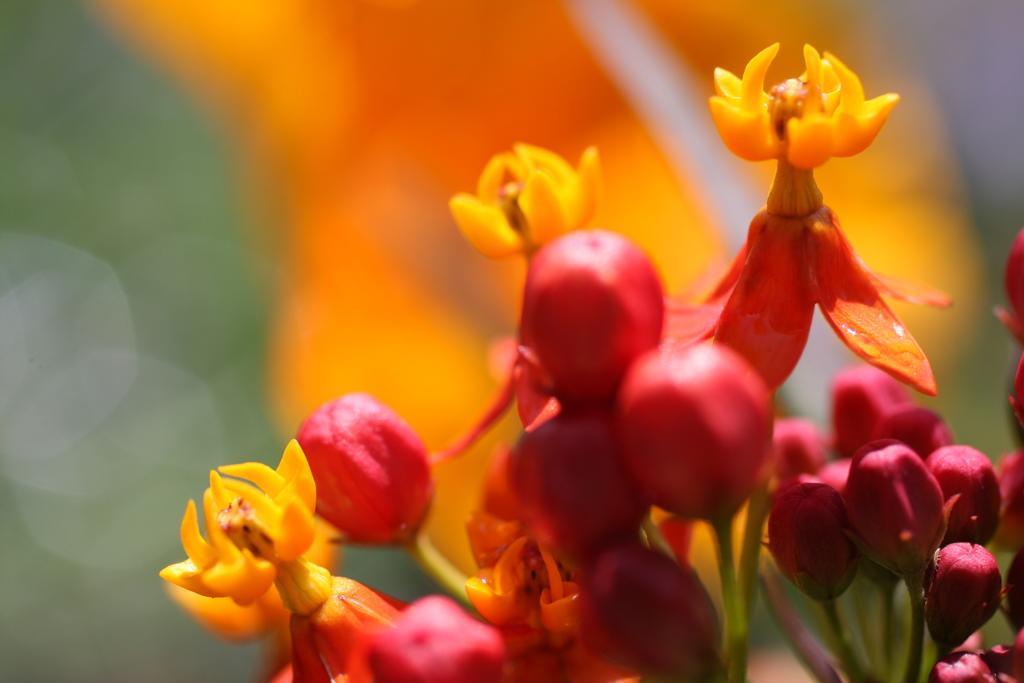Describe this image in one or two sentences. In this picture there are flowers and buds towards the left. The flowers are in yellow in color, buds are in pink in color. 